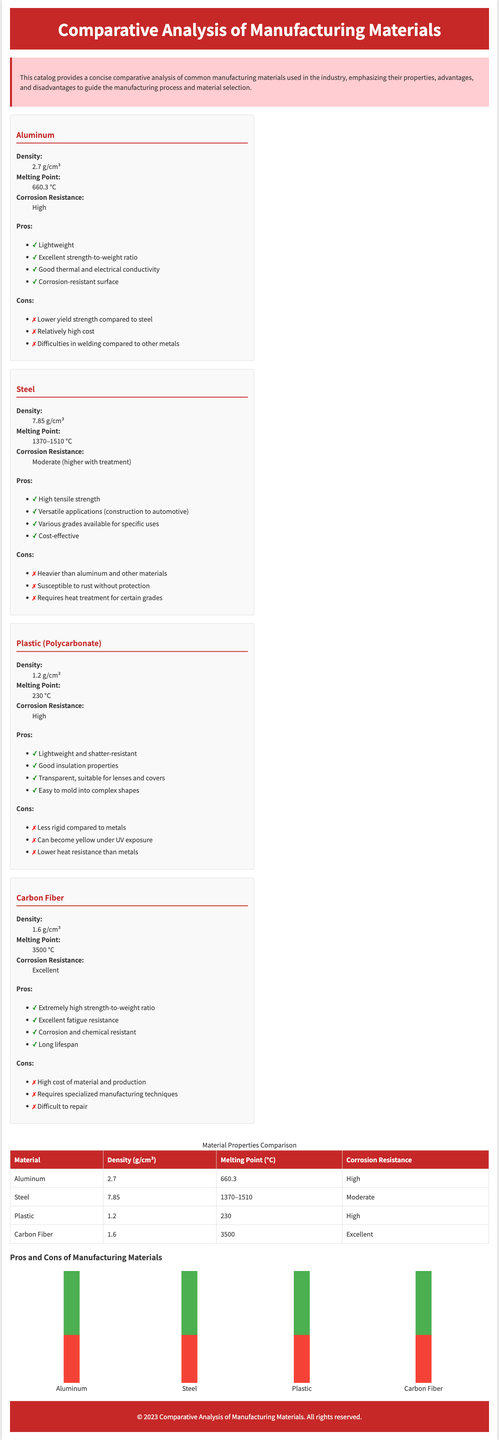what is the density of aluminum? The density of aluminum is provided in the properties section of the material description.
Answer: 2.7 g/cm³ what are the pros of carbon fiber? The pros of carbon fiber are listed in the pros section under the material description.
Answer: Extremely high strength-to-weight ratio, Excellent fatigue resistance, Corrosion and chemical resistant, Long lifespan what is the melting point of plastic? The melting point of plastic can be found in the properties section of the material description.
Answer: 230 °C which material has the highest corrosion resistance? The corrosion resistance ratings for all materials are listed in their respective properties sections, allowing for a comparison.
Answer: Carbon Fiber how many cons are listed for steel? The cons for each material are detailed in the cons section under the material description.
Answer: 3 